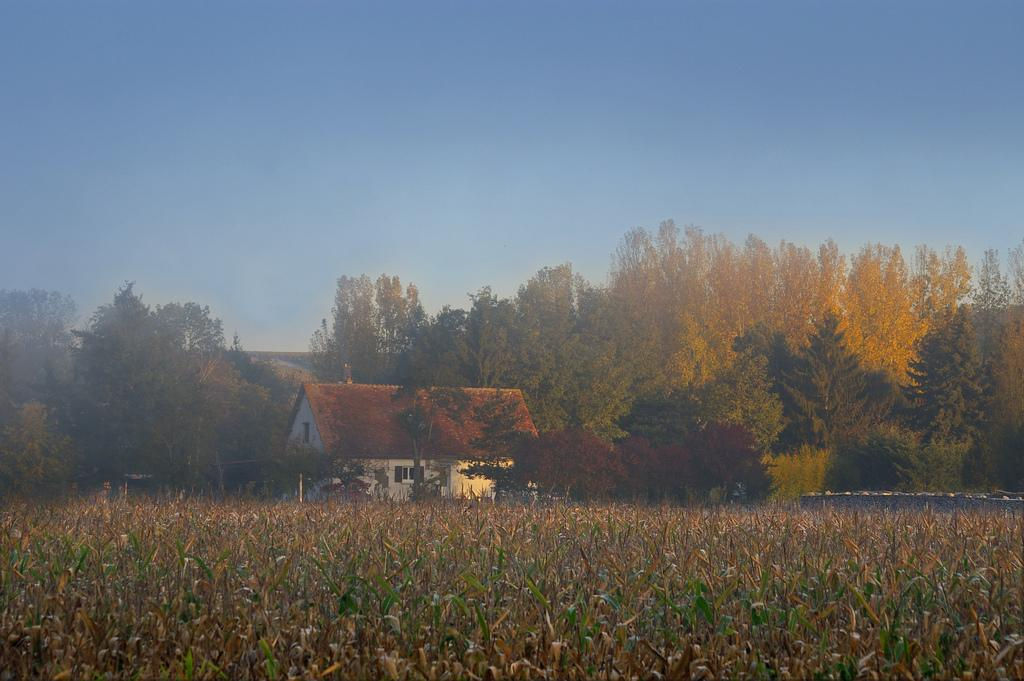What type of location is depicted at the bottom of the image? There is a farm at the bottom of the image. What structure is located in the middle of the image? There is a house in the middle of the image. What type of vegetation can be seen throughout the image? Trees are present throughout the image. What is visible at the top of the image? The sky is visible at the top of the image. What type of whistle can be heard coming from the farm in the image? There is no whistle present in the image, and therefore no sound can be heard. What type of jam is being prepared in the house in the image? There is no indication of jam preparation in the house in the image. 